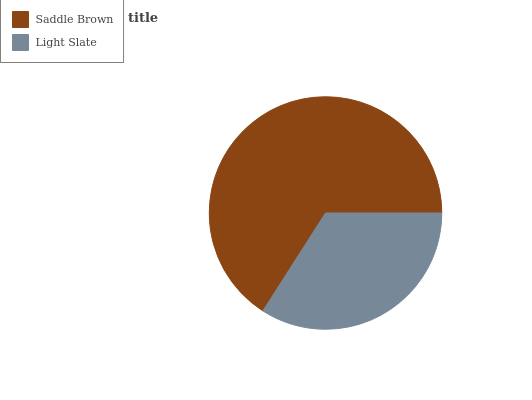Is Light Slate the minimum?
Answer yes or no. Yes. Is Saddle Brown the maximum?
Answer yes or no. Yes. Is Light Slate the maximum?
Answer yes or no. No. Is Saddle Brown greater than Light Slate?
Answer yes or no. Yes. Is Light Slate less than Saddle Brown?
Answer yes or no. Yes. Is Light Slate greater than Saddle Brown?
Answer yes or no. No. Is Saddle Brown less than Light Slate?
Answer yes or no. No. Is Saddle Brown the high median?
Answer yes or no. Yes. Is Light Slate the low median?
Answer yes or no. Yes. Is Light Slate the high median?
Answer yes or no. No. Is Saddle Brown the low median?
Answer yes or no. No. 